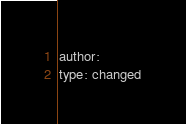<code> <loc_0><loc_0><loc_500><loc_500><_YAML_>author:
type: changed
</code> 